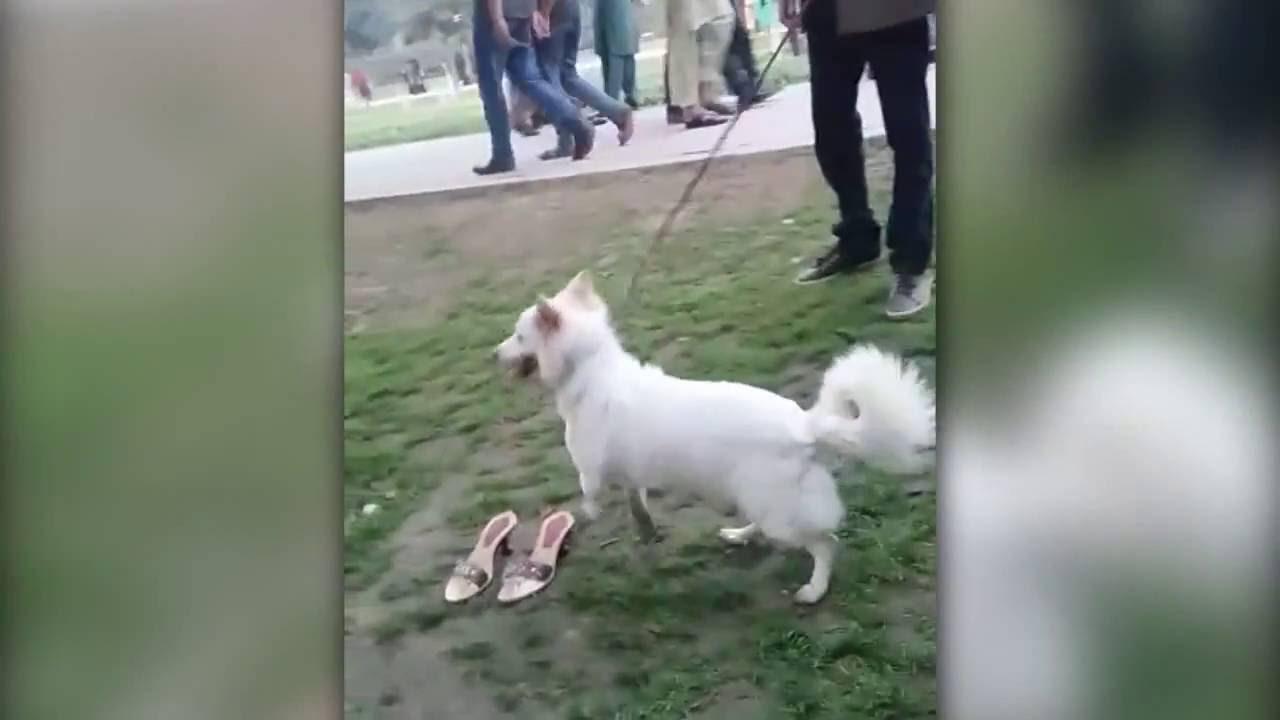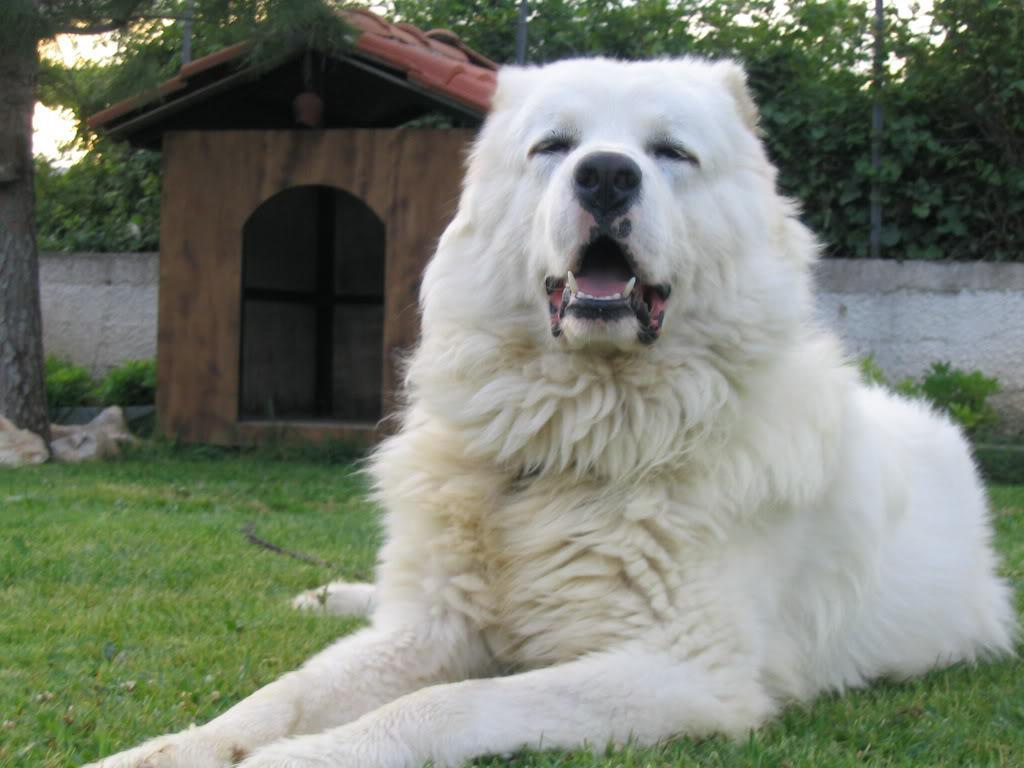The first image is the image on the left, the second image is the image on the right. Assess this claim about the two images: "One of the dogs is lying down on grass.". Correct or not? Answer yes or no. Yes. 